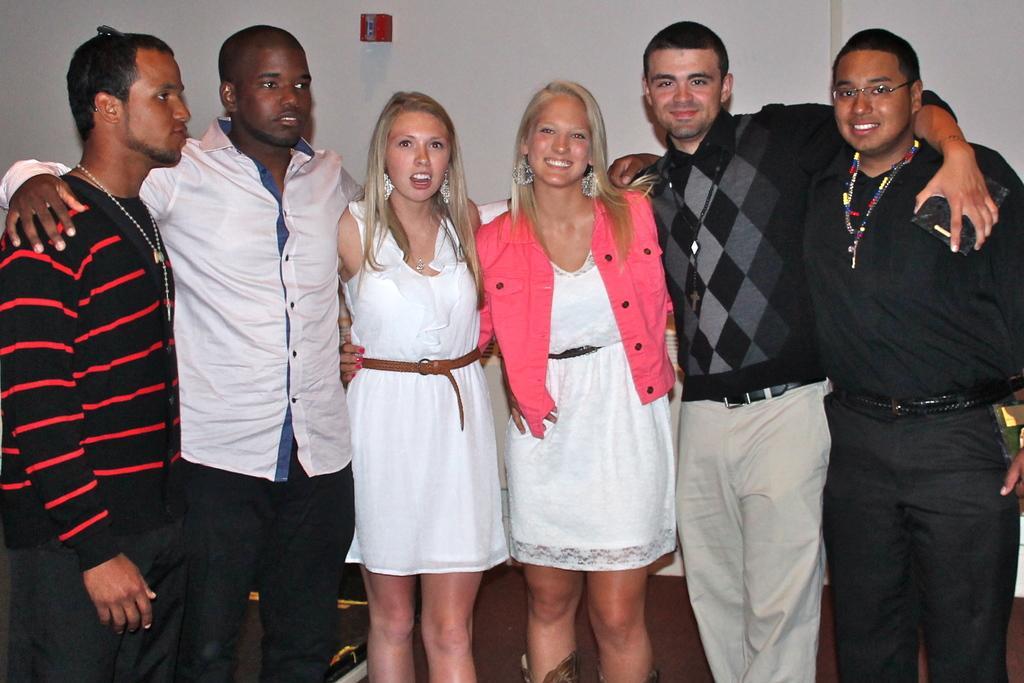Describe this image in one or two sentences. This image consists of group of persons standing and smiling. In the background there is a wall which is white in colour. 